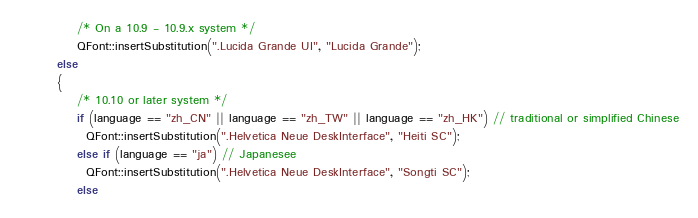Convert code to text. <code><loc_0><loc_0><loc_500><loc_500><_C++_>            /* On a 10.9 - 10.9.x system */
            QFont::insertSubstitution(".Lucida Grande UI", "Lucida Grande");
        else
        {
            /* 10.10 or later system */
            if (language == "zh_CN" || language == "zh_TW" || language == "zh_HK") // traditional or simplified Chinese
              QFont::insertSubstitution(".Helvetica Neue DeskInterface", "Heiti SC");
            else if (language == "ja") // Japanesee
              QFont::insertSubstitution(".Helvetica Neue DeskInterface", "Songti SC");
            else</code> 